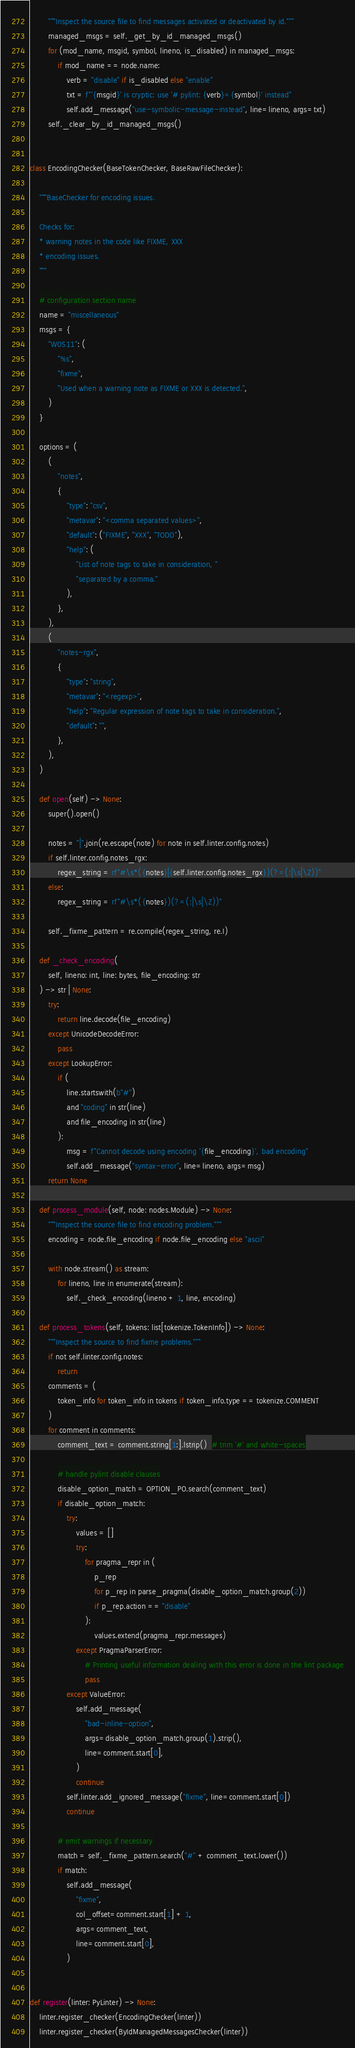Convert code to text. <code><loc_0><loc_0><loc_500><loc_500><_Python_>        """Inspect the source file to find messages activated or deactivated by id."""
        managed_msgs = self._get_by_id_managed_msgs()
        for (mod_name, msgid, symbol, lineno, is_disabled) in managed_msgs:
            if mod_name == node.name:
                verb = "disable" if is_disabled else "enable"
                txt = f"'{msgid}' is cryptic: use '# pylint: {verb}={symbol}' instead"
                self.add_message("use-symbolic-message-instead", line=lineno, args=txt)
        self._clear_by_id_managed_msgs()


class EncodingChecker(BaseTokenChecker, BaseRawFileChecker):

    """BaseChecker for encoding issues.

    Checks for:
    * warning notes in the code like FIXME, XXX
    * encoding issues.
    """

    # configuration section name
    name = "miscellaneous"
    msgs = {
        "W0511": (
            "%s",
            "fixme",
            "Used when a warning note as FIXME or XXX is detected.",
        )
    }

    options = (
        (
            "notes",
            {
                "type": "csv",
                "metavar": "<comma separated values>",
                "default": ("FIXME", "XXX", "TODO"),
                "help": (
                    "List of note tags to take in consideration, "
                    "separated by a comma."
                ),
            },
        ),
        (
            "notes-rgx",
            {
                "type": "string",
                "metavar": "<regexp>",
                "help": "Regular expression of note tags to take in consideration.",
                "default": "",
            },
        ),
    )

    def open(self) -> None:
        super().open()

        notes = "|".join(re.escape(note) for note in self.linter.config.notes)
        if self.linter.config.notes_rgx:
            regex_string = rf"#\s*({notes}|{self.linter.config.notes_rgx})(?=(:|\s|\Z))"
        else:
            regex_string = rf"#\s*({notes})(?=(:|\s|\Z))"

        self._fixme_pattern = re.compile(regex_string, re.I)

    def _check_encoding(
        self, lineno: int, line: bytes, file_encoding: str
    ) -> str | None:
        try:
            return line.decode(file_encoding)
        except UnicodeDecodeError:
            pass
        except LookupError:
            if (
                line.startswith(b"#")
                and "coding" in str(line)
                and file_encoding in str(line)
            ):
                msg = f"Cannot decode using encoding '{file_encoding}', bad encoding"
                self.add_message("syntax-error", line=lineno, args=msg)
        return None

    def process_module(self, node: nodes.Module) -> None:
        """Inspect the source file to find encoding problem."""
        encoding = node.file_encoding if node.file_encoding else "ascii"

        with node.stream() as stream:
            for lineno, line in enumerate(stream):
                self._check_encoding(lineno + 1, line, encoding)

    def process_tokens(self, tokens: list[tokenize.TokenInfo]) -> None:
        """Inspect the source to find fixme problems."""
        if not self.linter.config.notes:
            return
        comments = (
            token_info for token_info in tokens if token_info.type == tokenize.COMMENT
        )
        for comment in comments:
            comment_text = comment.string[1:].lstrip()  # trim '#' and white-spaces

            # handle pylint disable clauses
            disable_option_match = OPTION_PO.search(comment_text)
            if disable_option_match:
                try:
                    values = []
                    try:
                        for pragma_repr in (
                            p_rep
                            for p_rep in parse_pragma(disable_option_match.group(2))
                            if p_rep.action == "disable"
                        ):
                            values.extend(pragma_repr.messages)
                    except PragmaParserError:
                        # Printing useful information dealing with this error is done in the lint package
                        pass
                except ValueError:
                    self.add_message(
                        "bad-inline-option",
                        args=disable_option_match.group(1).strip(),
                        line=comment.start[0],
                    )
                    continue
                self.linter.add_ignored_message("fixme", line=comment.start[0])
                continue

            # emit warnings if necessary
            match = self._fixme_pattern.search("#" + comment_text.lower())
            if match:
                self.add_message(
                    "fixme",
                    col_offset=comment.start[1] + 1,
                    args=comment_text,
                    line=comment.start[0],
                )


def register(linter: PyLinter) -> None:
    linter.register_checker(EncodingChecker(linter))
    linter.register_checker(ByIdManagedMessagesChecker(linter))
</code> 